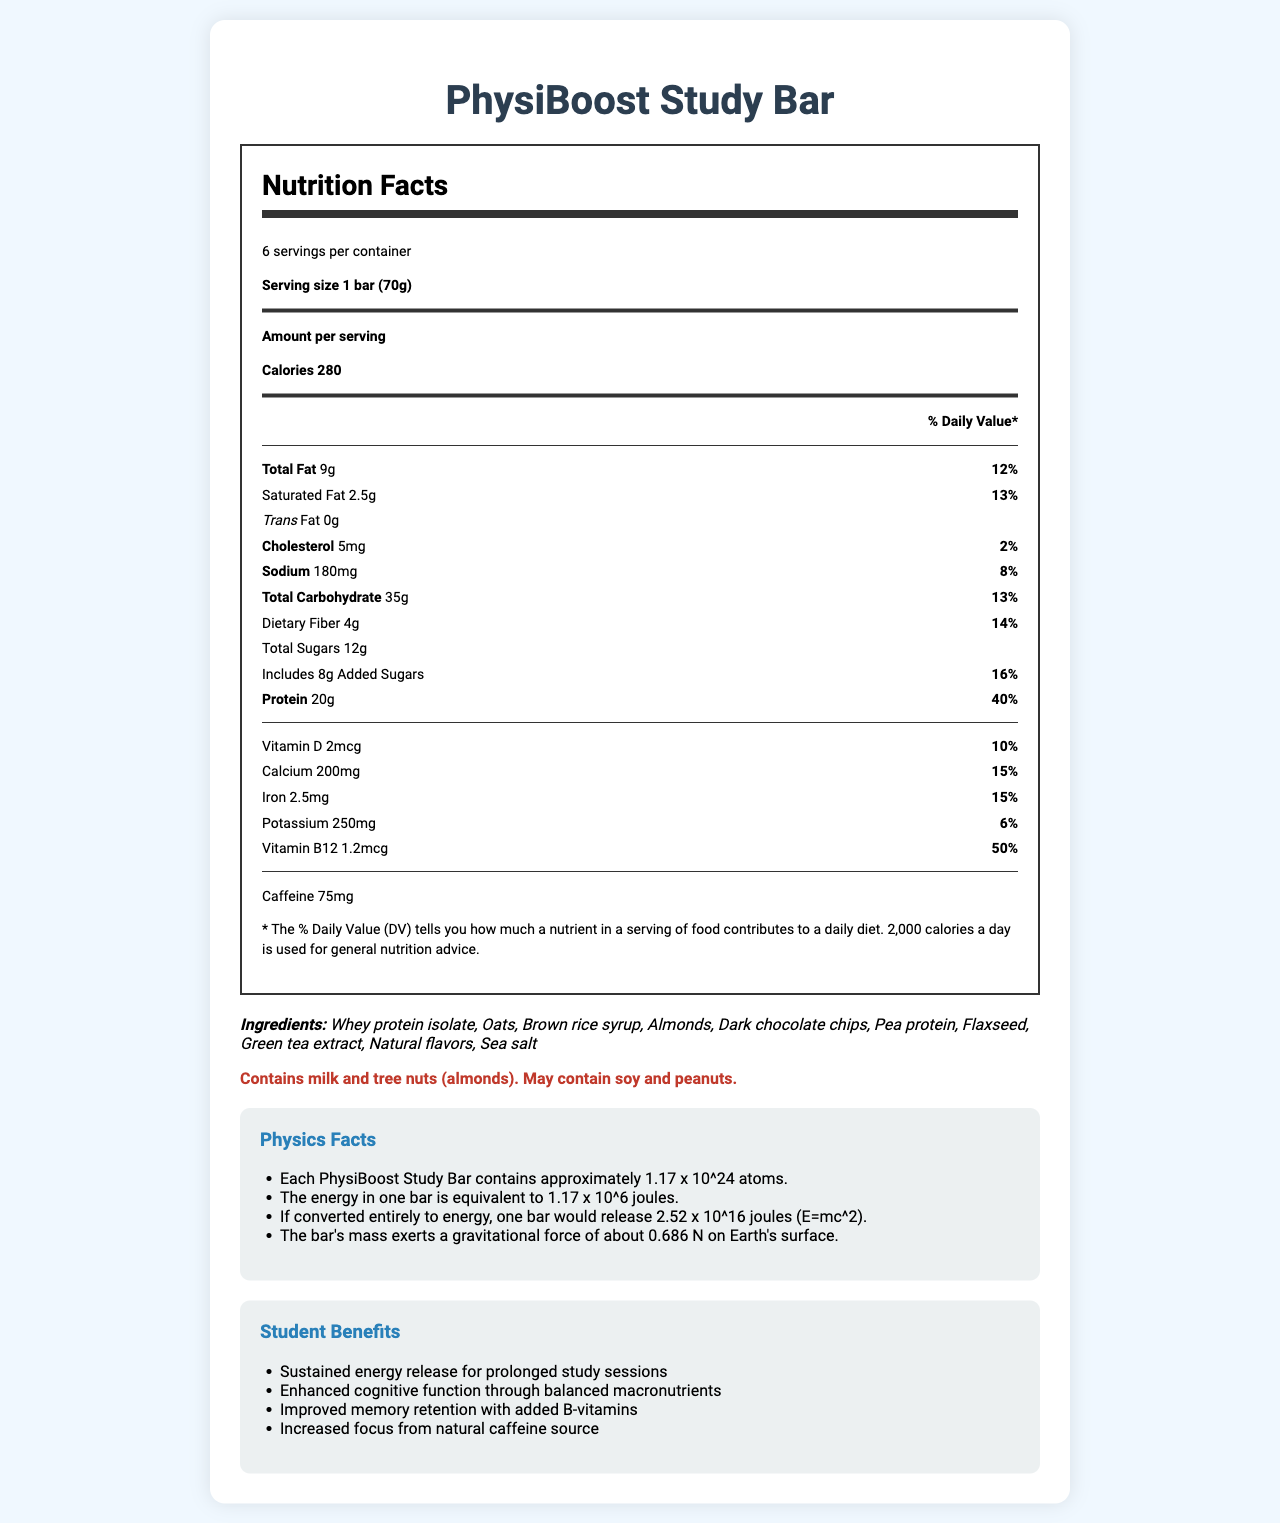what is the calories per serving? According to the document, the calories per serving of the PhysiBoost Study Bar is listed as 280.
Answer: 280 how much protein is in one serving of the PhysiBoost Study Bar? The document states that each serving contains 20 grams of protein.
Answer: 20g what is the serving size for the PhysiBoost Study Bar? The document lists the serving size as 1 bar, which is 70 grams.
Answer: 1 bar (70g) what are the two main benefits of consuming the PhysiBoost Study Bar for students? The document mentions several student benefits, including "Sustained energy release for prolonged study sessions" and "Enhanced cognitive function through balanced macronutrients."
Answer: Sustained energy release and enhanced cognitive function how many servings are there in one container of the PhysiBoost Study Bar? The document states that there are 6 servings per container.
Answer: 6 which of the following is a true statement about the fat content in the PhysiBoost Study Bar? 
A. It contains 0g of saturated fat 
B. It contains 9g of total fat 
C. It has no trans fat 
D. Both B and C The document indicates the bar contains 9 grams of total fat and no trans fat.
Answer: D how much sodium does each serving of the PhysiBoost Study Bar contain? 
A. 90mg 
B. 150mg 
C. 180mg 
D. 200mg The document states that each serving contains 180 milligrams of sodium.
Answer: C does the PhysiBoost Study Bar contain caffeine? The document mentions that the bar contains 75 milligrams of caffeine.
Answer: Yes what is the main idea of the document? The document is centered around presenting the nutritional facts, benefits, and additional information of the PhysiBoost Study Bar, pointing out why it is beneficial for students, especially during extensive study periods.
Answer: The document provides detailed nutritional information about the PhysiBoost Study Bar, highlighting its benefits for students during late-night study sessions, its ingredients, allergen information, and physics-related energy facts. can you determine the retail price of one container of the PhysiBoost Study Bar from the document? The document does not provide any information about the retail price of the product.
Answer: Not enough information 